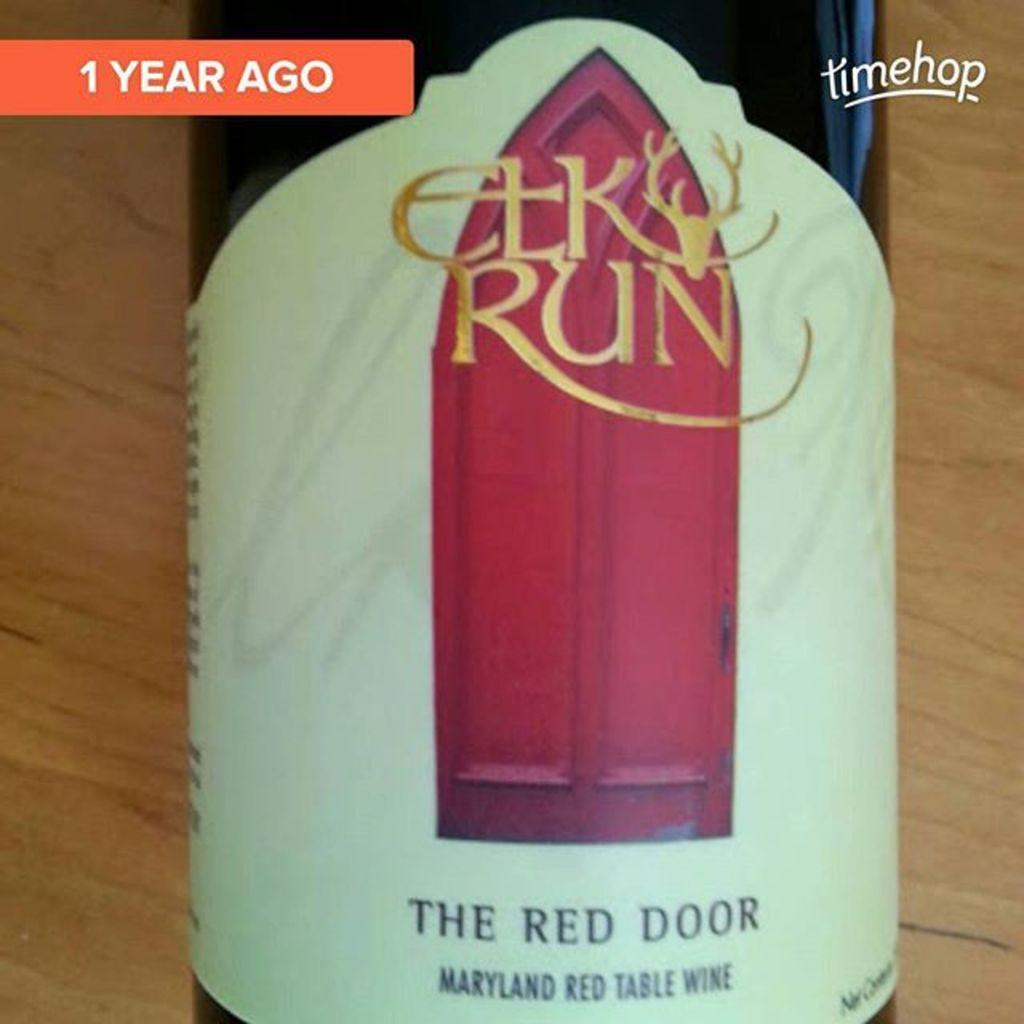<image>
Provide a brief description of the given image. Bottle of Elk Run placed on a wooden surface. 